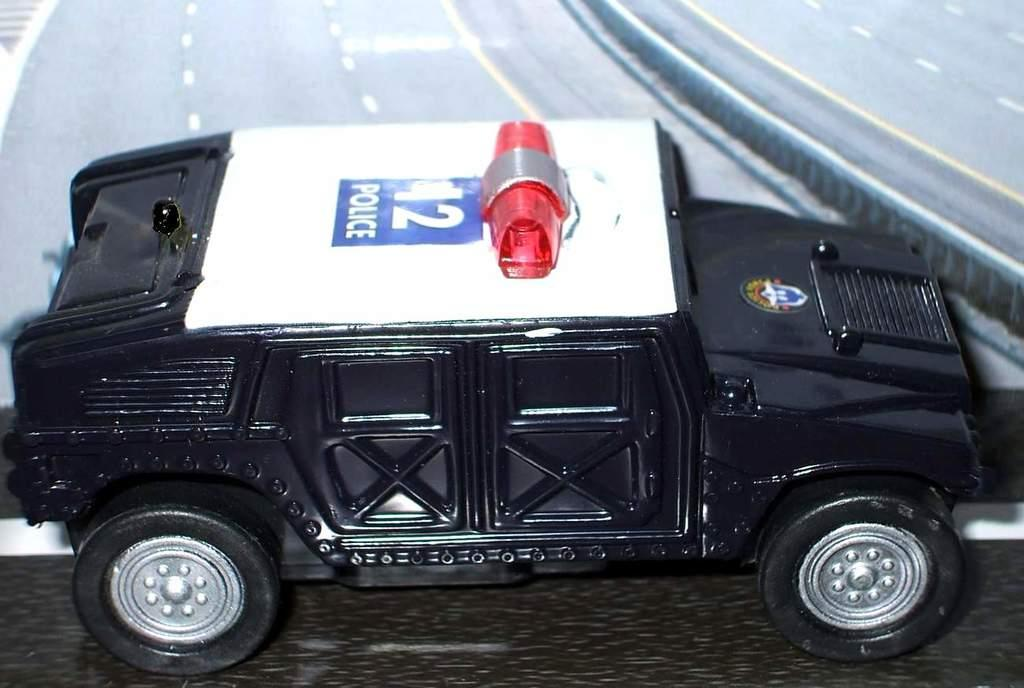What type of toy is in the image? There is a vehicle toy in the image. Where is the toy located? The toy is on the floor. What can be seen behind the toy? There is a road visible behind the toy. What is written or printed on the toy? There is text on the toy. What sound does the bell on the vehicle toy make in the image? There is no bell present on the vehicle toy in the image. 